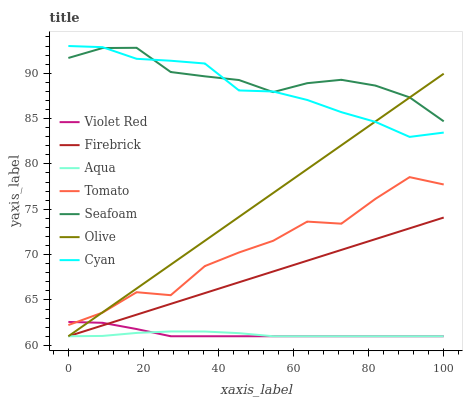Does Aqua have the minimum area under the curve?
Answer yes or no. Yes. Does Seafoam have the maximum area under the curve?
Answer yes or no. Yes. Does Violet Red have the minimum area under the curve?
Answer yes or no. No. Does Violet Red have the maximum area under the curve?
Answer yes or no. No. Is Firebrick the smoothest?
Answer yes or no. Yes. Is Tomato the roughest?
Answer yes or no. Yes. Is Violet Red the smoothest?
Answer yes or no. No. Is Violet Red the roughest?
Answer yes or no. No. Does Violet Red have the lowest value?
Answer yes or no. Yes. Does Seafoam have the lowest value?
Answer yes or no. No. Does Cyan have the highest value?
Answer yes or no. Yes. Does Violet Red have the highest value?
Answer yes or no. No. Is Tomato less than Seafoam?
Answer yes or no. Yes. Is Seafoam greater than Tomato?
Answer yes or no. Yes. Does Violet Red intersect Tomato?
Answer yes or no. Yes. Is Violet Red less than Tomato?
Answer yes or no. No. Is Violet Red greater than Tomato?
Answer yes or no. No. Does Tomato intersect Seafoam?
Answer yes or no. No. 